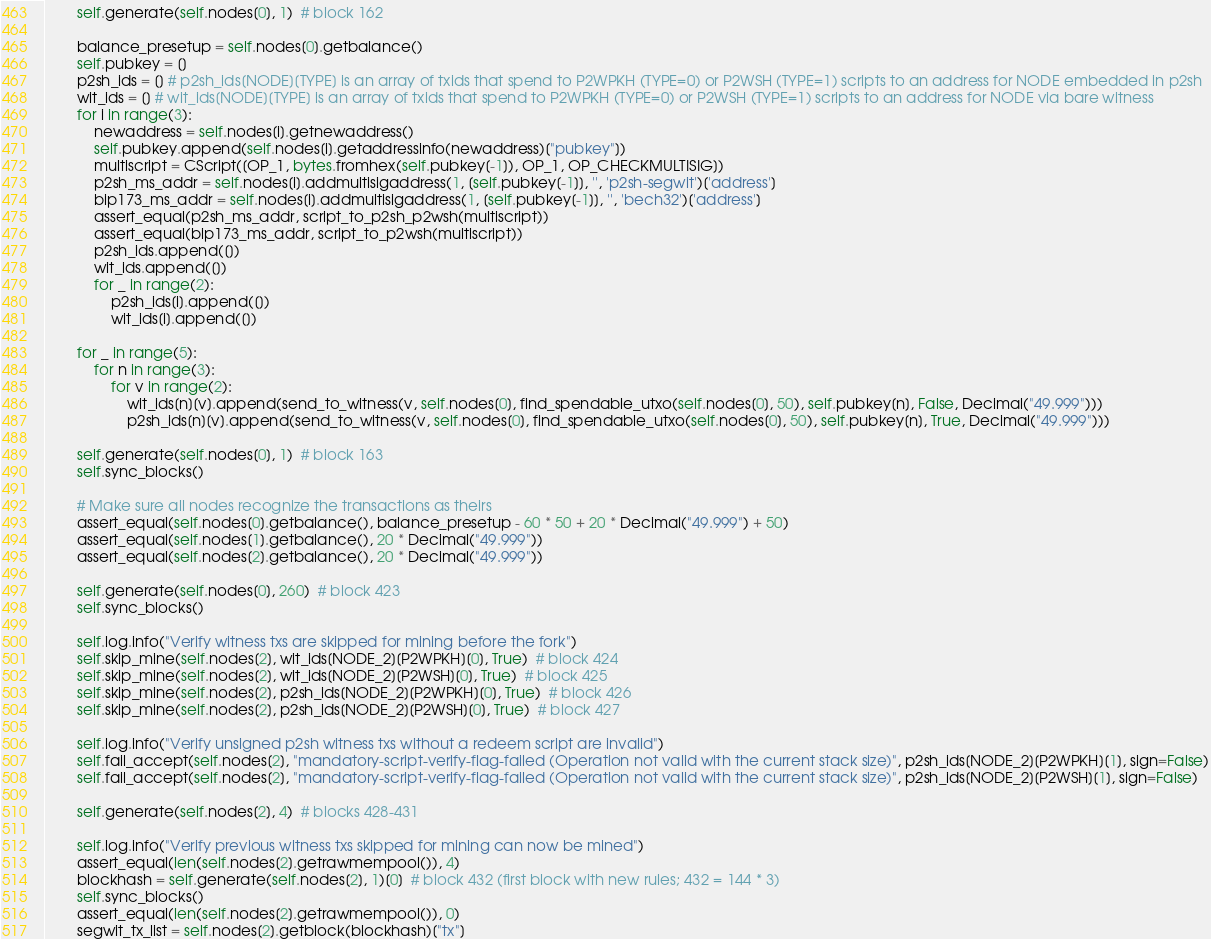<code> <loc_0><loc_0><loc_500><loc_500><_Python_>        self.generate(self.nodes[0], 1)  # block 162

        balance_presetup = self.nodes[0].getbalance()
        self.pubkey = []
        p2sh_ids = [] # p2sh_ids[NODE][TYPE] is an array of txids that spend to P2WPKH (TYPE=0) or P2WSH (TYPE=1) scripts to an address for NODE embedded in p2sh
        wit_ids = [] # wit_ids[NODE][TYPE] is an array of txids that spend to P2WPKH (TYPE=0) or P2WSH (TYPE=1) scripts to an address for NODE via bare witness
        for i in range(3):
            newaddress = self.nodes[i].getnewaddress()
            self.pubkey.append(self.nodes[i].getaddressinfo(newaddress)["pubkey"])
            multiscript = CScript([OP_1, bytes.fromhex(self.pubkey[-1]), OP_1, OP_CHECKMULTISIG])
            p2sh_ms_addr = self.nodes[i].addmultisigaddress(1, [self.pubkey[-1]], '', 'p2sh-segwit')['address']
            bip173_ms_addr = self.nodes[i].addmultisigaddress(1, [self.pubkey[-1]], '', 'bech32')['address']
            assert_equal(p2sh_ms_addr, script_to_p2sh_p2wsh(multiscript))
            assert_equal(bip173_ms_addr, script_to_p2wsh(multiscript))
            p2sh_ids.append([])
            wit_ids.append([])
            for _ in range(2):
                p2sh_ids[i].append([])
                wit_ids[i].append([])

        for _ in range(5):
            for n in range(3):
                for v in range(2):
                    wit_ids[n][v].append(send_to_witness(v, self.nodes[0], find_spendable_utxo(self.nodes[0], 50), self.pubkey[n], False, Decimal("49.999")))
                    p2sh_ids[n][v].append(send_to_witness(v, self.nodes[0], find_spendable_utxo(self.nodes[0], 50), self.pubkey[n], True, Decimal("49.999")))

        self.generate(self.nodes[0], 1)  # block 163
        self.sync_blocks()

        # Make sure all nodes recognize the transactions as theirs
        assert_equal(self.nodes[0].getbalance(), balance_presetup - 60 * 50 + 20 * Decimal("49.999") + 50)
        assert_equal(self.nodes[1].getbalance(), 20 * Decimal("49.999"))
        assert_equal(self.nodes[2].getbalance(), 20 * Decimal("49.999"))

        self.generate(self.nodes[0], 260)  # block 423
        self.sync_blocks()

        self.log.info("Verify witness txs are skipped for mining before the fork")
        self.skip_mine(self.nodes[2], wit_ids[NODE_2][P2WPKH][0], True)  # block 424
        self.skip_mine(self.nodes[2], wit_ids[NODE_2][P2WSH][0], True)  # block 425
        self.skip_mine(self.nodes[2], p2sh_ids[NODE_2][P2WPKH][0], True)  # block 426
        self.skip_mine(self.nodes[2], p2sh_ids[NODE_2][P2WSH][0], True)  # block 427

        self.log.info("Verify unsigned p2sh witness txs without a redeem script are invalid")
        self.fail_accept(self.nodes[2], "mandatory-script-verify-flag-failed (Operation not valid with the current stack size)", p2sh_ids[NODE_2][P2WPKH][1], sign=False)
        self.fail_accept(self.nodes[2], "mandatory-script-verify-flag-failed (Operation not valid with the current stack size)", p2sh_ids[NODE_2][P2WSH][1], sign=False)

        self.generate(self.nodes[2], 4)  # blocks 428-431

        self.log.info("Verify previous witness txs skipped for mining can now be mined")
        assert_equal(len(self.nodes[2].getrawmempool()), 4)
        blockhash = self.generate(self.nodes[2], 1)[0]  # block 432 (first block with new rules; 432 = 144 * 3)
        self.sync_blocks()
        assert_equal(len(self.nodes[2].getrawmempool()), 0)
        segwit_tx_list = self.nodes[2].getblock(blockhash)["tx"]</code> 